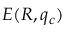Convert formula to latex. <formula><loc_0><loc_0><loc_500><loc_500>E ( R , q _ { c } )</formula> 